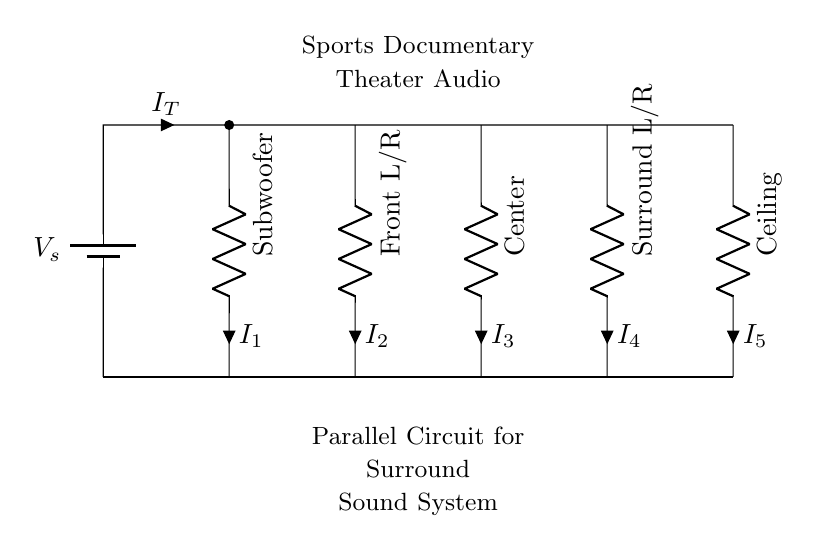What is the type of circuit shown? The circuit is a parallel circuit, characterized by multiple components connected across the same voltage source, allowing for independent current paths.
Answer: Parallel What is the purpose of the subwoofer in the circuit? The subwoofer provides low-frequency audio, enhancing the surround sound experience, especially in action-packed sports documentaries where bass is significant.
Answer: Low-frequency audio How many resistors are in this circuit? There are five resistors, each representing a different speaker in the surround sound system, connected in parallel.
Answer: Five What is the total current entering the circuit? The total current is represented as I_T in the circuit, which is the sum of all individual currents (I_1 to I_5) through the different speakers.
Answer: I_T Which component is responsible for the center audio channel? The center component is responsible for the central audio channel, vital for dialogue and critical sound effects during the documentary.
Answer: Center Explain why the circuit is designed in parallel for sound systems. In parallel circuits, each speaker receives the same voltage from the source and can operate independently. This ensures that even if one speaker fails, the rest continue to function, which is crucial for maintaining sound quality in a theater.
Answer: Independent operation 